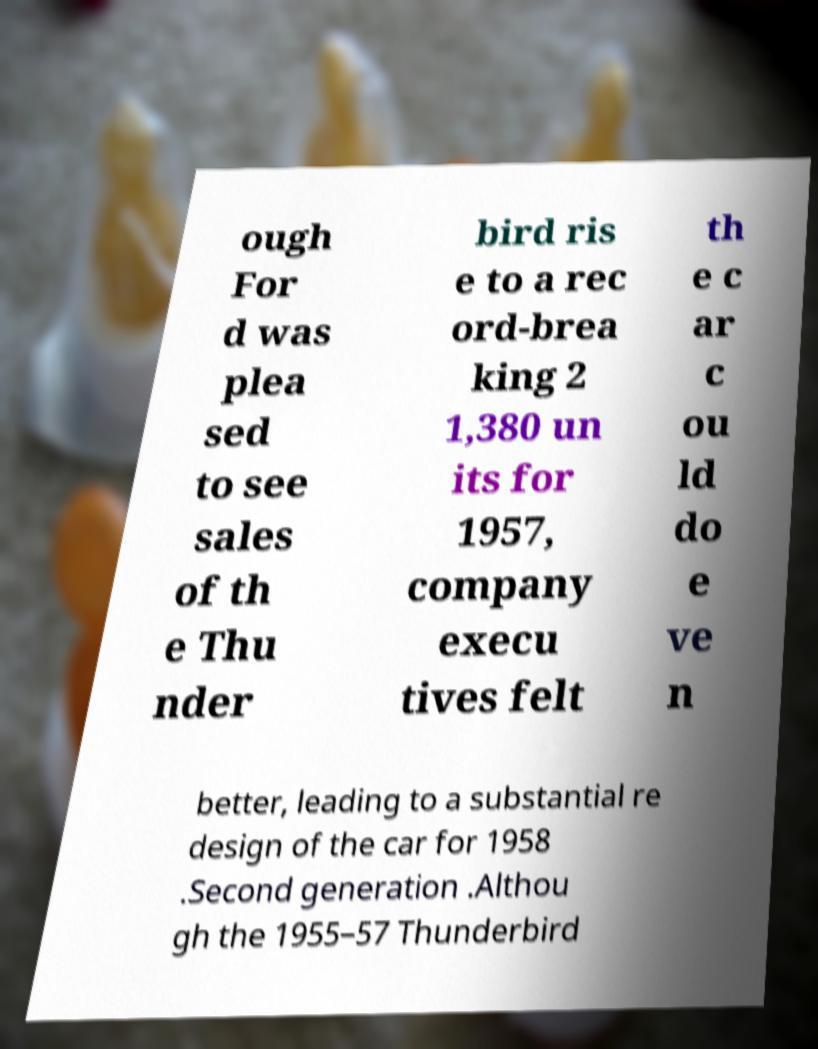What messages or text are displayed in this image? I need them in a readable, typed format. ough For d was plea sed to see sales of th e Thu nder bird ris e to a rec ord-brea king 2 1,380 un its for 1957, company execu tives felt th e c ar c ou ld do e ve n better, leading to a substantial re design of the car for 1958 .Second generation .Althou gh the 1955–57 Thunderbird 